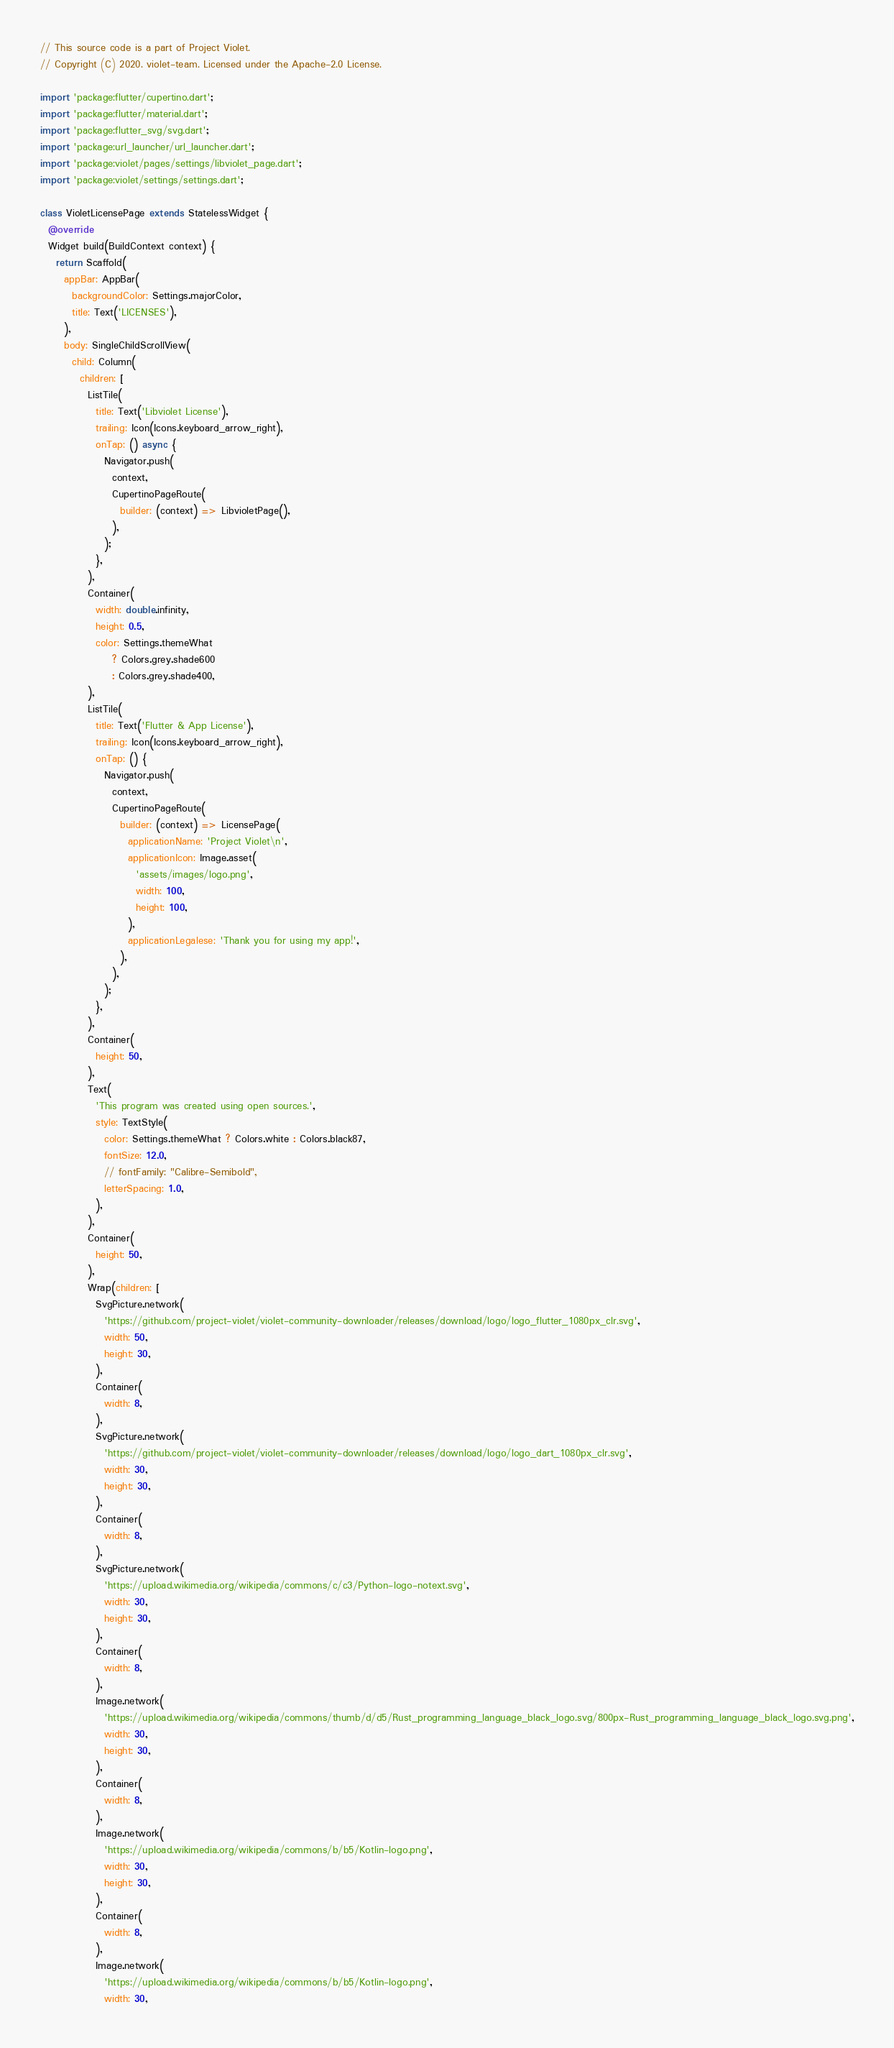Convert code to text. <code><loc_0><loc_0><loc_500><loc_500><_Dart_>// This source code is a part of Project Violet.
// Copyright (C) 2020. violet-team. Licensed under the Apache-2.0 License.

import 'package:flutter/cupertino.dart';
import 'package:flutter/material.dart';
import 'package:flutter_svg/svg.dart';
import 'package:url_launcher/url_launcher.dart';
import 'package:violet/pages/settings/libviolet_page.dart';
import 'package:violet/settings/settings.dart';

class VioletLicensePage extends StatelessWidget {
  @override
  Widget build(BuildContext context) {
    return Scaffold(
      appBar: AppBar(
        backgroundColor: Settings.majorColor,
        title: Text('LICENSES'),
      ),
      body: SingleChildScrollView(
        child: Column(
          children: [
            ListTile(
              title: Text('Libviolet License'),
              trailing: Icon(Icons.keyboard_arrow_right),
              onTap: () async {
                Navigator.push(
                  context,
                  CupertinoPageRoute(
                    builder: (context) => LibvioletPage(),
                  ),
                );
              },
            ),
            Container(
              width: double.infinity,
              height: 0.5,
              color: Settings.themeWhat
                  ? Colors.grey.shade600
                  : Colors.grey.shade400,
            ),
            ListTile(
              title: Text('Flutter & App License'),
              trailing: Icon(Icons.keyboard_arrow_right),
              onTap: () {
                Navigator.push(
                  context,
                  CupertinoPageRoute(
                    builder: (context) => LicensePage(
                      applicationName: 'Project Violet\n',
                      applicationIcon: Image.asset(
                        'assets/images/logo.png',
                        width: 100,
                        height: 100,
                      ),
                      applicationLegalese: 'Thank you for using my app!',
                    ),
                  ),
                );
              },
            ),
            Container(
              height: 50,
            ),
            Text(
              'This program was created using open sources.',
              style: TextStyle(
                color: Settings.themeWhat ? Colors.white : Colors.black87,
                fontSize: 12.0,
                // fontFamily: "Calibre-Semibold",
                letterSpacing: 1.0,
              ),
            ),
            Container(
              height: 50,
            ),
            Wrap(children: [
              SvgPicture.network(
                'https://github.com/project-violet/violet-community-downloader/releases/download/logo/logo_flutter_1080px_clr.svg',
                width: 50,
                height: 30,
              ),
              Container(
                width: 8,
              ),
              SvgPicture.network(
                'https://github.com/project-violet/violet-community-downloader/releases/download/logo/logo_dart_1080px_clr.svg',
                width: 30,
                height: 30,
              ),
              Container(
                width: 8,
              ),
              SvgPicture.network(
                'https://upload.wikimedia.org/wikipedia/commons/c/c3/Python-logo-notext.svg',
                width: 30,
                height: 30,
              ),
              Container(
                width: 8,
              ),
              Image.network(
                'https://upload.wikimedia.org/wikipedia/commons/thumb/d/d5/Rust_programming_language_black_logo.svg/800px-Rust_programming_language_black_logo.svg.png',
                width: 30,
                height: 30,
              ),
              Container(
                width: 8,
              ),
              Image.network(
                'https://upload.wikimedia.org/wikipedia/commons/b/b5/Kotlin-logo.png',
                width: 30,
                height: 30,
              ),
              Container(
                width: 8,
              ),
              Image.network(
                'https://upload.wikimedia.org/wikipedia/commons/b/b5/Kotlin-logo.png',
                width: 30,</code> 